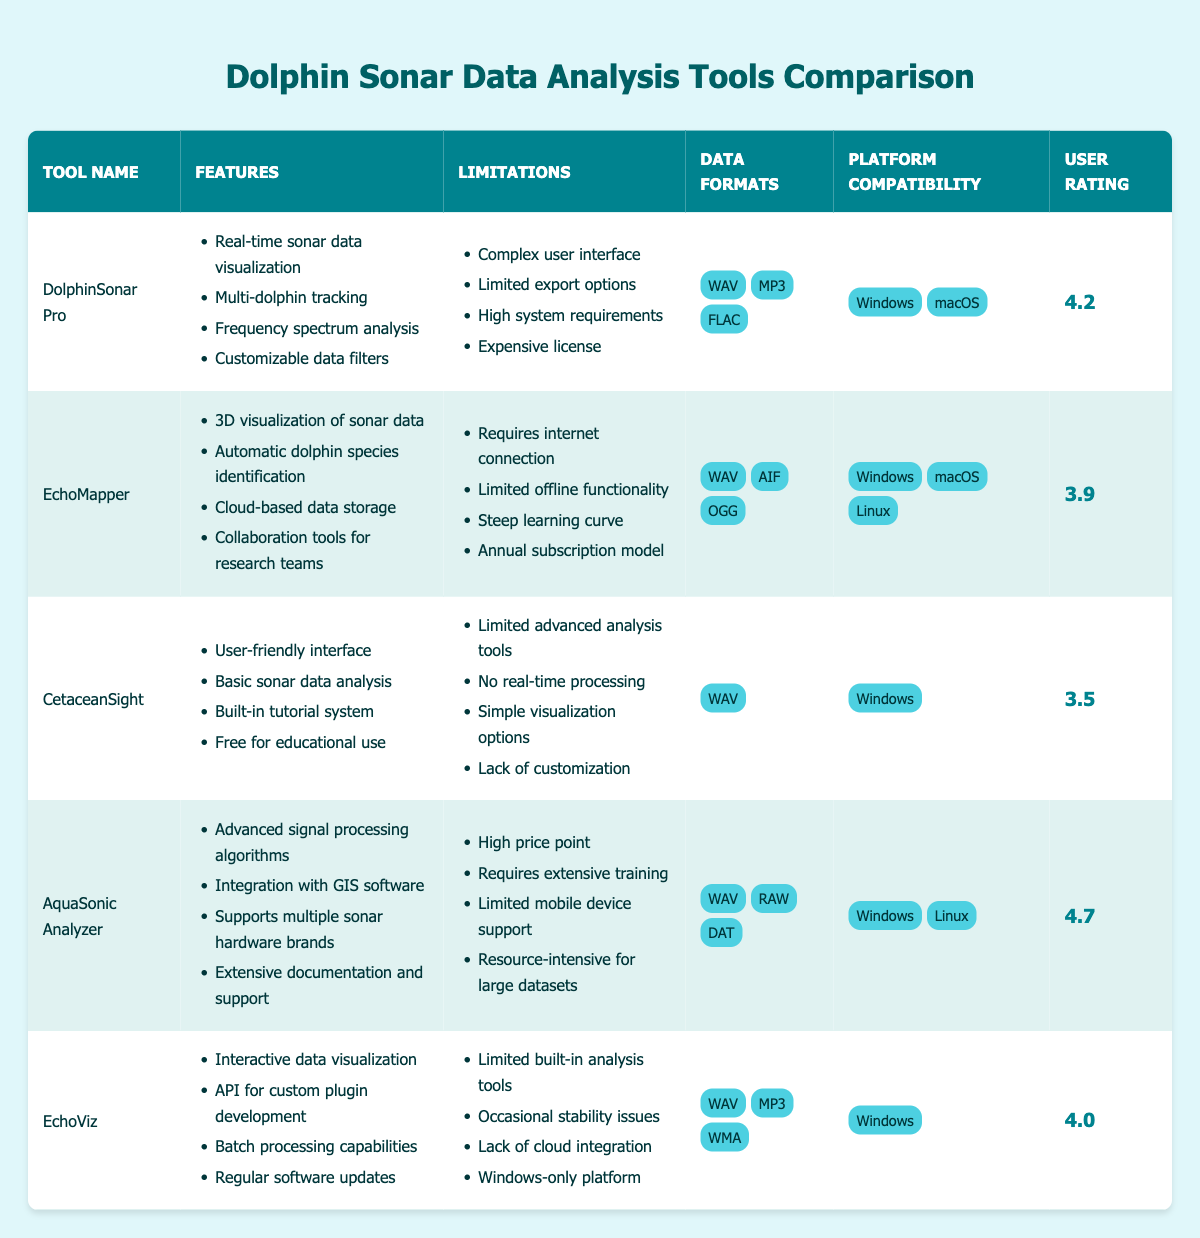What are the features of AquaSonic Analyzer? There is a list of features associated with AquaSonic Analyzer in the table. They include advanced signal processing algorithms, integration with GIS software, support for multiple sonar hardware brands, and extensive documentation and support.
Answer: Advanced signal processing algorithms, integration with GIS software, supports multiple sonar hardware brands, extensive documentation and support Which tool has the highest user rating? The user rating for each tool is listed in the table. Upon comparison, AquaSonic Analyzer has the highest rating at 4.7.
Answer: AquaSonic Analyzer Does CetaceanSight provide real-time processing capabilities? The limitations section for CetaceanSight explicitly states "No real-time processing," indicating that it does not provide this capability.
Answer: No What is the average user rating of all tools listed? The user ratings of the tools are: 4.2, 3.9, 3.5, 4.7, and 4.0. To find the average, sum these ratings: (4.2 + 3.9 + 3.5 + 4.7 + 4.0) = 20.3. Divide this sum by the number of tools, which is 5; thus, the average is 20.3 / 5 = 4.06.
Answer: 4.06 Is EchoMapper compatible with Linux? The compatibility section for EchoMapper lists Windows, macOS, and Linux. Therefore, it is indeed compatible with Linux.
Answer: Yes Which tool(s) have limited advanced analysis tools? The limitations for both CetaceanSight and EchoViz mention "Limited built-in analysis tools." Thus, both fall under this category.
Answer: CetaceanSight and EchoViz What is the data format supported by CetaceanSight? The table states that CetaceanSight only supports the WAV format for data. There are no other formats listed for this tool.
Answer: WAV Calculate the total number of features available across all tools. The number of features for each tool is: DolphinSonar Pro (4), EchoMapper (4), CetaceanSight (4), AquaSonic Analyzer (4), EchoViz (4). Adding these gives us a total of 4 + 4 + 4 + 4 + 4 = 20 features across all tools.
Answer: 20 